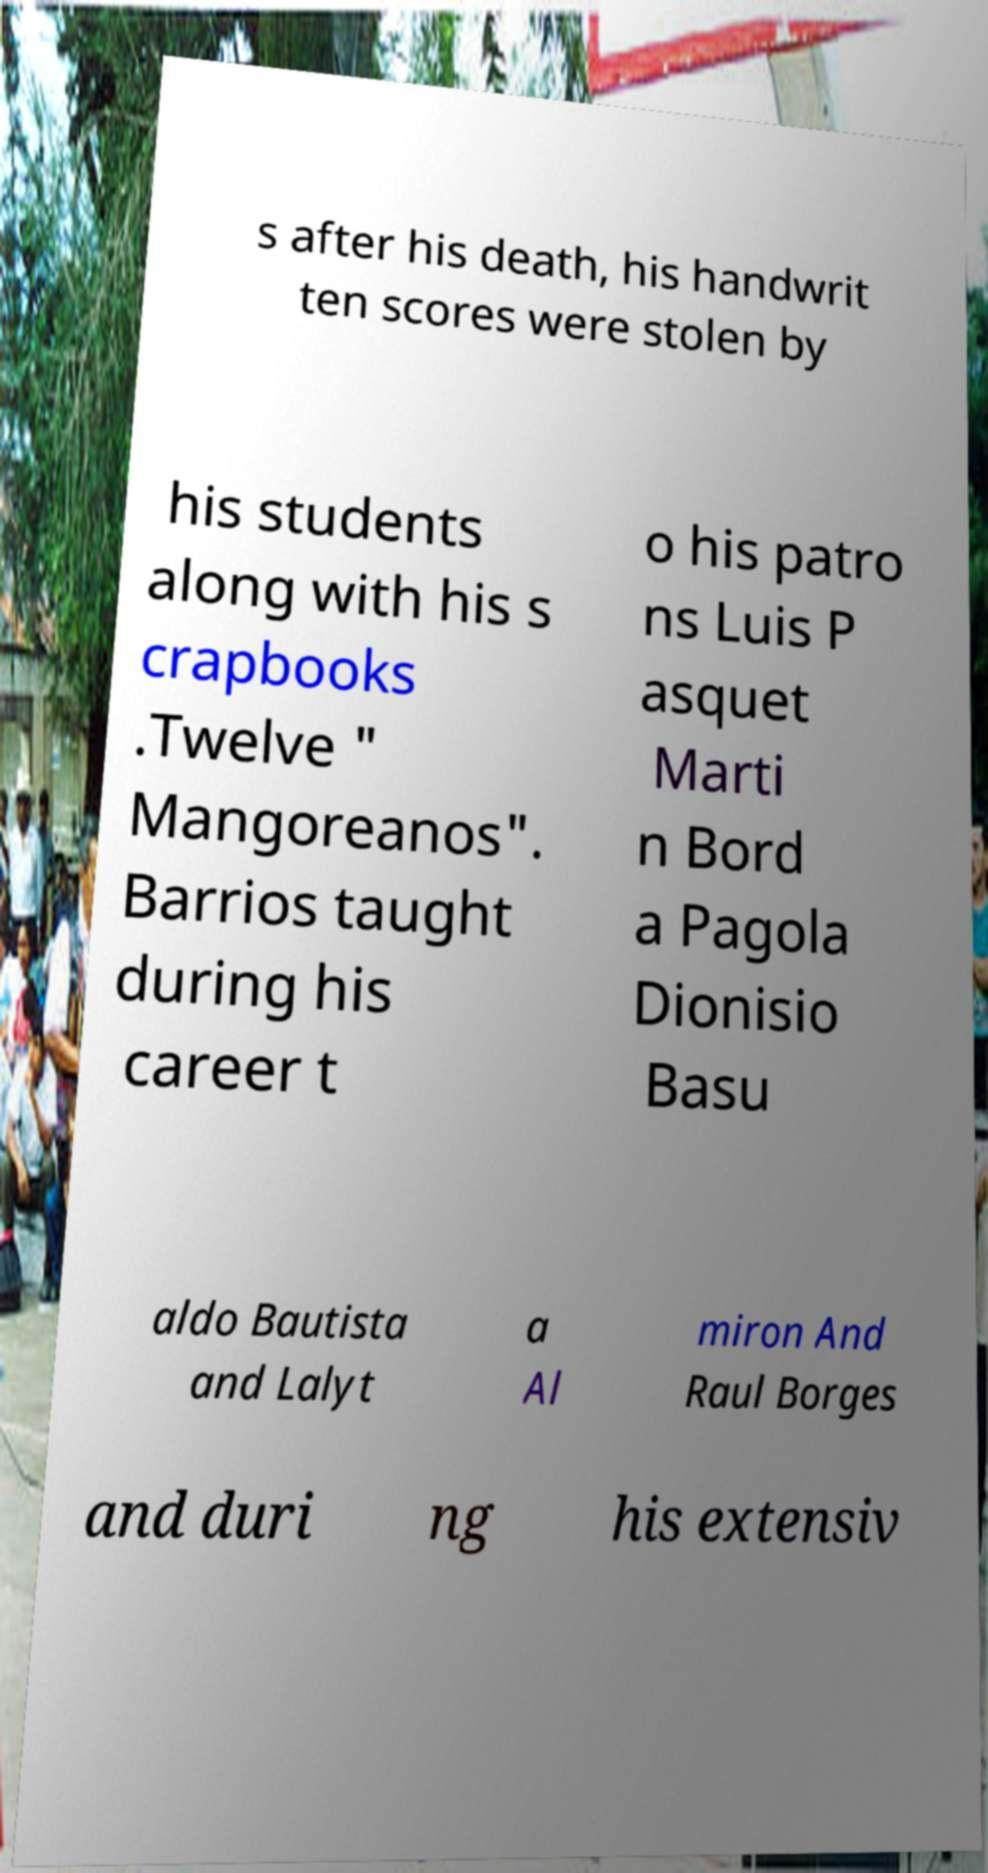Could you assist in decoding the text presented in this image and type it out clearly? s after his death, his handwrit ten scores were stolen by his students along with his s crapbooks .Twelve " Mangoreanos". Barrios taught during his career t o his patro ns Luis P asquet Marti n Bord a Pagola Dionisio Basu aldo Bautista and Lalyt a Al miron And Raul Borges and duri ng his extensiv 